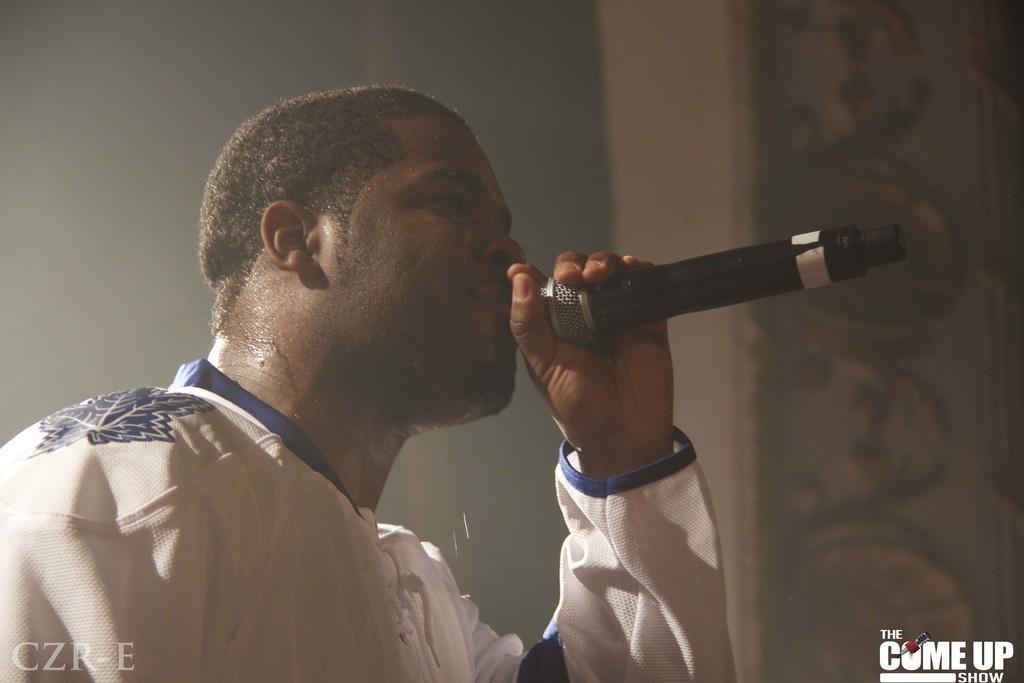Describe this image in one or two sentences. In this picture I can see a man holding a mike, there is blur background, and there are watermarks on the image. 